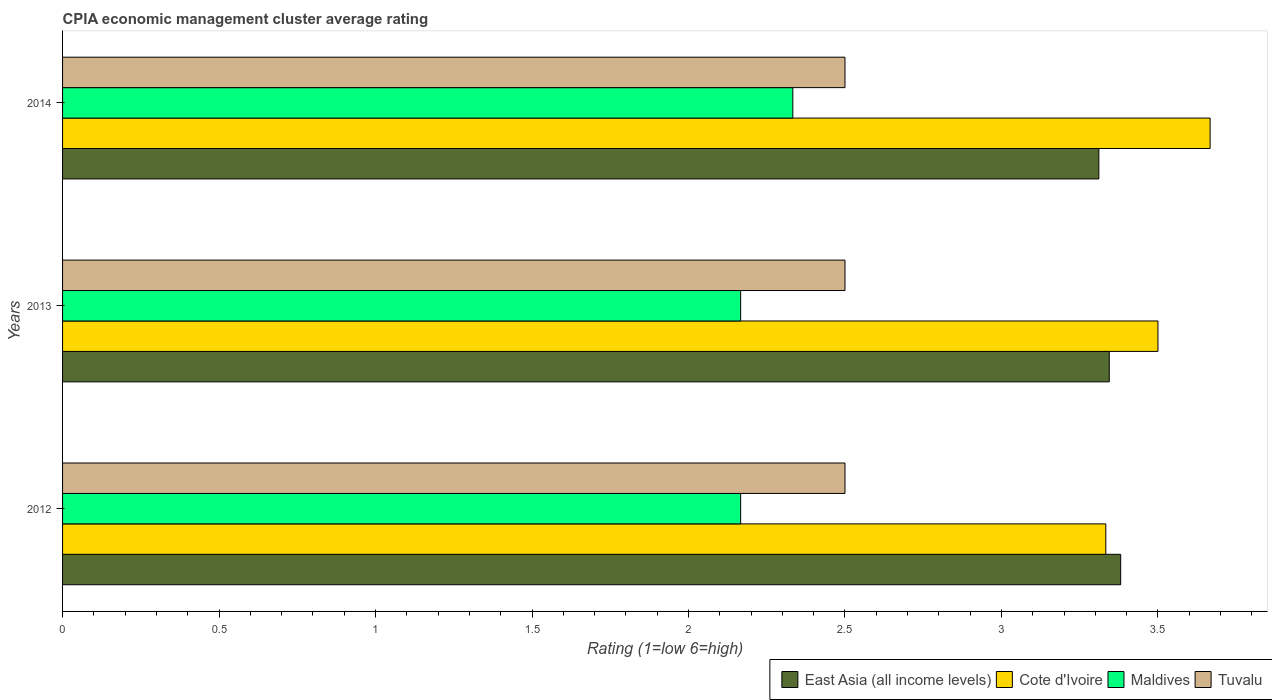How many groups of bars are there?
Provide a succinct answer. 3. Are the number of bars per tick equal to the number of legend labels?
Offer a terse response. Yes. How many bars are there on the 3rd tick from the top?
Ensure brevity in your answer.  4. In how many cases, is the number of bars for a given year not equal to the number of legend labels?
Keep it short and to the point. 0. What is the CPIA rating in Cote d'Ivoire in 2012?
Make the answer very short. 3.33. Across all years, what is the maximum CPIA rating in Tuvalu?
Offer a very short reply. 2.5. Across all years, what is the minimum CPIA rating in East Asia (all income levels)?
Keep it short and to the point. 3.31. In which year was the CPIA rating in East Asia (all income levels) maximum?
Offer a very short reply. 2012. What is the total CPIA rating in Maldives in the graph?
Provide a succinct answer. 6.67. What is the difference between the CPIA rating in Tuvalu in 2012 and that in 2013?
Make the answer very short. 0. What is the difference between the CPIA rating in Tuvalu in 2014 and the CPIA rating in Cote d'Ivoire in 2012?
Give a very brief answer. -0.83. What is the average CPIA rating in Cote d'Ivoire per year?
Keep it short and to the point. 3.5. In the year 2012, what is the difference between the CPIA rating in Cote d'Ivoire and CPIA rating in Tuvalu?
Offer a terse response. 0.83. What is the ratio of the CPIA rating in Cote d'Ivoire in 2012 to that in 2013?
Offer a very short reply. 0.95. Is the CPIA rating in Maldives in 2013 less than that in 2014?
Your answer should be compact. Yes. Is the difference between the CPIA rating in Cote d'Ivoire in 2013 and 2014 greater than the difference between the CPIA rating in Tuvalu in 2013 and 2014?
Provide a succinct answer. No. What is the difference between the highest and the second highest CPIA rating in East Asia (all income levels)?
Provide a succinct answer. 0.04. What is the difference between the highest and the lowest CPIA rating in East Asia (all income levels)?
Keep it short and to the point. 0.07. In how many years, is the CPIA rating in Tuvalu greater than the average CPIA rating in Tuvalu taken over all years?
Make the answer very short. 0. Is the sum of the CPIA rating in Tuvalu in 2012 and 2014 greater than the maximum CPIA rating in Maldives across all years?
Make the answer very short. Yes. What does the 2nd bar from the top in 2014 represents?
Make the answer very short. Maldives. What does the 4th bar from the bottom in 2012 represents?
Provide a short and direct response. Tuvalu. Is it the case that in every year, the sum of the CPIA rating in Cote d'Ivoire and CPIA rating in Tuvalu is greater than the CPIA rating in Maldives?
Offer a very short reply. Yes. Are all the bars in the graph horizontal?
Provide a short and direct response. Yes. How many years are there in the graph?
Your answer should be very brief. 3. What is the difference between two consecutive major ticks on the X-axis?
Provide a short and direct response. 0.5. Are the values on the major ticks of X-axis written in scientific E-notation?
Offer a terse response. No. Does the graph contain any zero values?
Offer a very short reply. No. Does the graph contain grids?
Provide a succinct answer. No. How many legend labels are there?
Your answer should be very brief. 4. What is the title of the graph?
Keep it short and to the point. CPIA economic management cluster average rating. Does "Uganda" appear as one of the legend labels in the graph?
Offer a terse response. No. What is the label or title of the X-axis?
Give a very brief answer. Rating (1=low 6=high). What is the label or title of the Y-axis?
Offer a terse response. Years. What is the Rating (1=low 6=high) in East Asia (all income levels) in 2012?
Make the answer very short. 3.38. What is the Rating (1=low 6=high) of Cote d'Ivoire in 2012?
Ensure brevity in your answer.  3.33. What is the Rating (1=low 6=high) of Maldives in 2012?
Your response must be concise. 2.17. What is the Rating (1=low 6=high) of Tuvalu in 2012?
Ensure brevity in your answer.  2.5. What is the Rating (1=low 6=high) of East Asia (all income levels) in 2013?
Ensure brevity in your answer.  3.34. What is the Rating (1=low 6=high) in Maldives in 2013?
Offer a very short reply. 2.17. What is the Rating (1=low 6=high) of Tuvalu in 2013?
Offer a terse response. 2.5. What is the Rating (1=low 6=high) of East Asia (all income levels) in 2014?
Offer a terse response. 3.31. What is the Rating (1=low 6=high) in Cote d'Ivoire in 2014?
Your answer should be very brief. 3.67. What is the Rating (1=low 6=high) of Maldives in 2014?
Ensure brevity in your answer.  2.33. What is the Rating (1=low 6=high) in Tuvalu in 2014?
Ensure brevity in your answer.  2.5. Across all years, what is the maximum Rating (1=low 6=high) of East Asia (all income levels)?
Keep it short and to the point. 3.38. Across all years, what is the maximum Rating (1=low 6=high) in Cote d'Ivoire?
Provide a succinct answer. 3.67. Across all years, what is the maximum Rating (1=low 6=high) of Maldives?
Provide a short and direct response. 2.33. Across all years, what is the minimum Rating (1=low 6=high) of East Asia (all income levels)?
Keep it short and to the point. 3.31. Across all years, what is the minimum Rating (1=low 6=high) in Cote d'Ivoire?
Offer a terse response. 3.33. Across all years, what is the minimum Rating (1=low 6=high) of Maldives?
Your answer should be very brief. 2.17. Across all years, what is the minimum Rating (1=low 6=high) of Tuvalu?
Keep it short and to the point. 2.5. What is the total Rating (1=low 6=high) in East Asia (all income levels) in the graph?
Provide a succinct answer. 10.04. What is the difference between the Rating (1=low 6=high) in East Asia (all income levels) in 2012 and that in 2013?
Ensure brevity in your answer.  0.04. What is the difference between the Rating (1=low 6=high) in Cote d'Ivoire in 2012 and that in 2013?
Offer a terse response. -0.17. What is the difference between the Rating (1=low 6=high) of Maldives in 2012 and that in 2013?
Give a very brief answer. 0. What is the difference between the Rating (1=low 6=high) of East Asia (all income levels) in 2012 and that in 2014?
Give a very brief answer. 0.07. What is the difference between the Rating (1=low 6=high) of Maldives in 2012 and that in 2014?
Give a very brief answer. -0.17. What is the difference between the Rating (1=low 6=high) of Tuvalu in 2013 and that in 2014?
Your answer should be compact. 0. What is the difference between the Rating (1=low 6=high) of East Asia (all income levels) in 2012 and the Rating (1=low 6=high) of Cote d'Ivoire in 2013?
Ensure brevity in your answer.  -0.12. What is the difference between the Rating (1=low 6=high) of East Asia (all income levels) in 2012 and the Rating (1=low 6=high) of Maldives in 2013?
Ensure brevity in your answer.  1.21. What is the difference between the Rating (1=low 6=high) of East Asia (all income levels) in 2012 and the Rating (1=low 6=high) of Tuvalu in 2013?
Ensure brevity in your answer.  0.88. What is the difference between the Rating (1=low 6=high) in Cote d'Ivoire in 2012 and the Rating (1=low 6=high) in Maldives in 2013?
Give a very brief answer. 1.17. What is the difference between the Rating (1=low 6=high) of East Asia (all income levels) in 2012 and the Rating (1=low 6=high) of Cote d'Ivoire in 2014?
Make the answer very short. -0.29. What is the difference between the Rating (1=low 6=high) of East Asia (all income levels) in 2012 and the Rating (1=low 6=high) of Maldives in 2014?
Offer a very short reply. 1.05. What is the difference between the Rating (1=low 6=high) in East Asia (all income levels) in 2012 and the Rating (1=low 6=high) in Tuvalu in 2014?
Give a very brief answer. 0.88. What is the difference between the Rating (1=low 6=high) of Cote d'Ivoire in 2012 and the Rating (1=low 6=high) of Maldives in 2014?
Give a very brief answer. 1. What is the difference between the Rating (1=low 6=high) in Cote d'Ivoire in 2012 and the Rating (1=low 6=high) in Tuvalu in 2014?
Offer a terse response. 0.83. What is the difference between the Rating (1=low 6=high) in East Asia (all income levels) in 2013 and the Rating (1=low 6=high) in Cote d'Ivoire in 2014?
Offer a very short reply. -0.32. What is the difference between the Rating (1=low 6=high) in East Asia (all income levels) in 2013 and the Rating (1=low 6=high) in Maldives in 2014?
Offer a terse response. 1.01. What is the difference between the Rating (1=low 6=high) in East Asia (all income levels) in 2013 and the Rating (1=low 6=high) in Tuvalu in 2014?
Your answer should be compact. 0.84. What is the average Rating (1=low 6=high) in East Asia (all income levels) per year?
Make the answer very short. 3.35. What is the average Rating (1=low 6=high) of Cote d'Ivoire per year?
Provide a short and direct response. 3.5. What is the average Rating (1=low 6=high) in Maldives per year?
Make the answer very short. 2.22. What is the average Rating (1=low 6=high) in Tuvalu per year?
Your answer should be very brief. 2.5. In the year 2012, what is the difference between the Rating (1=low 6=high) of East Asia (all income levels) and Rating (1=low 6=high) of Cote d'Ivoire?
Offer a very short reply. 0.05. In the year 2012, what is the difference between the Rating (1=low 6=high) of East Asia (all income levels) and Rating (1=low 6=high) of Maldives?
Make the answer very short. 1.21. In the year 2012, what is the difference between the Rating (1=low 6=high) of East Asia (all income levels) and Rating (1=low 6=high) of Tuvalu?
Give a very brief answer. 0.88. In the year 2012, what is the difference between the Rating (1=low 6=high) in Cote d'Ivoire and Rating (1=low 6=high) in Tuvalu?
Provide a succinct answer. 0.83. In the year 2012, what is the difference between the Rating (1=low 6=high) of Maldives and Rating (1=low 6=high) of Tuvalu?
Keep it short and to the point. -0.33. In the year 2013, what is the difference between the Rating (1=low 6=high) of East Asia (all income levels) and Rating (1=low 6=high) of Cote d'Ivoire?
Ensure brevity in your answer.  -0.16. In the year 2013, what is the difference between the Rating (1=low 6=high) of East Asia (all income levels) and Rating (1=low 6=high) of Maldives?
Provide a short and direct response. 1.18. In the year 2013, what is the difference between the Rating (1=low 6=high) of East Asia (all income levels) and Rating (1=low 6=high) of Tuvalu?
Offer a terse response. 0.84. In the year 2013, what is the difference between the Rating (1=low 6=high) of Cote d'Ivoire and Rating (1=low 6=high) of Tuvalu?
Provide a short and direct response. 1. In the year 2013, what is the difference between the Rating (1=low 6=high) in Maldives and Rating (1=low 6=high) in Tuvalu?
Offer a terse response. -0.33. In the year 2014, what is the difference between the Rating (1=low 6=high) of East Asia (all income levels) and Rating (1=low 6=high) of Cote d'Ivoire?
Your answer should be compact. -0.36. In the year 2014, what is the difference between the Rating (1=low 6=high) of East Asia (all income levels) and Rating (1=low 6=high) of Maldives?
Provide a short and direct response. 0.98. In the year 2014, what is the difference between the Rating (1=low 6=high) of East Asia (all income levels) and Rating (1=low 6=high) of Tuvalu?
Offer a very short reply. 0.81. In the year 2014, what is the difference between the Rating (1=low 6=high) in Cote d'Ivoire and Rating (1=low 6=high) in Maldives?
Ensure brevity in your answer.  1.33. In the year 2014, what is the difference between the Rating (1=low 6=high) in Cote d'Ivoire and Rating (1=low 6=high) in Tuvalu?
Ensure brevity in your answer.  1.17. In the year 2014, what is the difference between the Rating (1=low 6=high) of Maldives and Rating (1=low 6=high) of Tuvalu?
Provide a succinct answer. -0.17. What is the ratio of the Rating (1=low 6=high) of East Asia (all income levels) in 2012 to that in 2013?
Make the answer very short. 1.01. What is the ratio of the Rating (1=low 6=high) of East Asia (all income levels) in 2012 to that in 2014?
Your response must be concise. 1.02. What is the ratio of the Rating (1=low 6=high) of Cote d'Ivoire in 2012 to that in 2014?
Give a very brief answer. 0.91. What is the ratio of the Rating (1=low 6=high) in East Asia (all income levels) in 2013 to that in 2014?
Keep it short and to the point. 1.01. What is the ratio of the Rating (1=low 6=high) of Cote d'Ivoire in 2013 to that in 2014?
Make the answer very short. 0.95. What is the ratio of the Rating (1=low 6=high) of Maldives in 2013 to that in 2014?
Provide a succinct answer. 0.93. What is the difference between the highest and the second highest Rating (1=low 6=high) in East Asia (all income levels)?
Keep it short and to the point. 0.04. What is the difference between the highest and the second highest Rating (1=low 6=high) in Cote d'Ivoire?
Your answer should be compact. 0.17. What is the difference between the highest and the second highest Rating (1=low 6=high) of Maldives?
Keep it short and to the point. 0.17. What is the difference between the highest and the lowest Rating (1=low 6=high) of East Asia (all income levels)?
Provide a short and direct response. 0.07. 